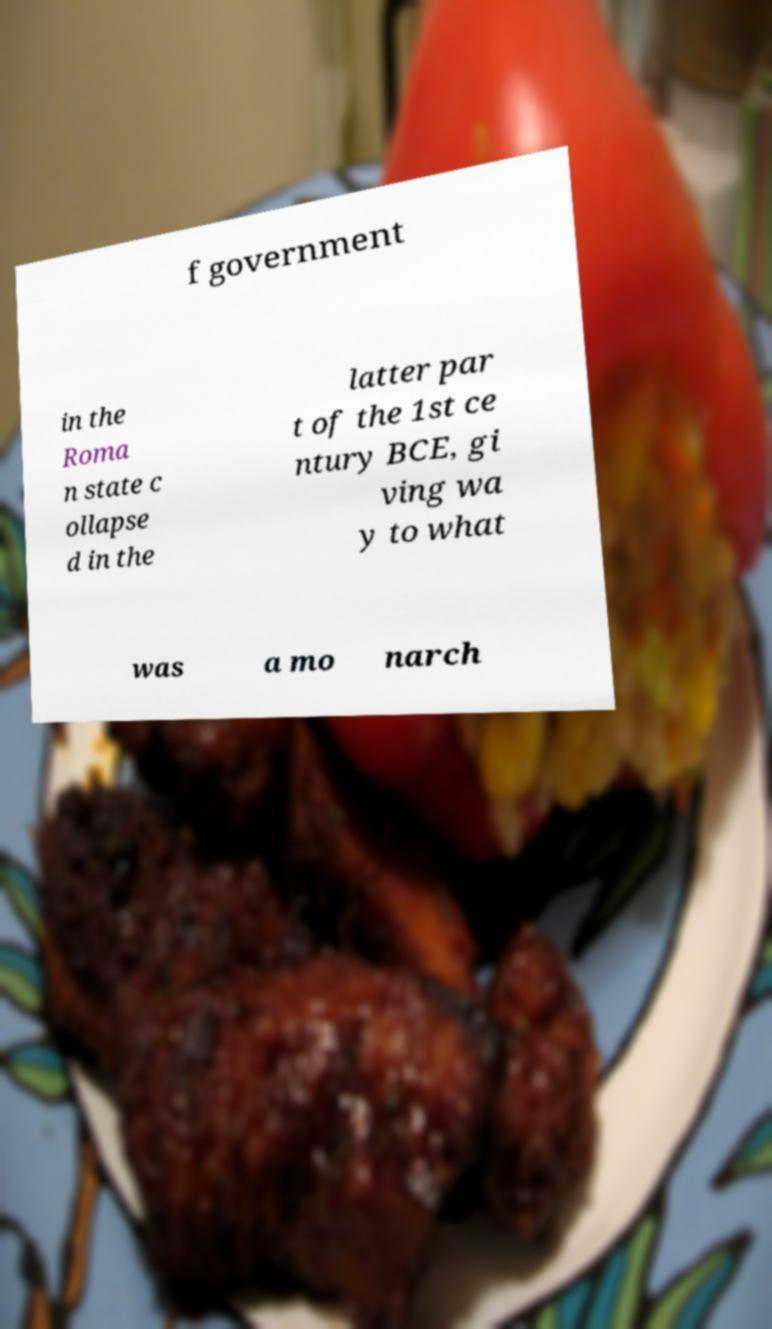Please read and relay the text visible in this image. What does it say? f government in the Roma n state c ollapse d in the latter par t of the 1st ce ntury BCE, gi ving wa y to what was a mo narch 